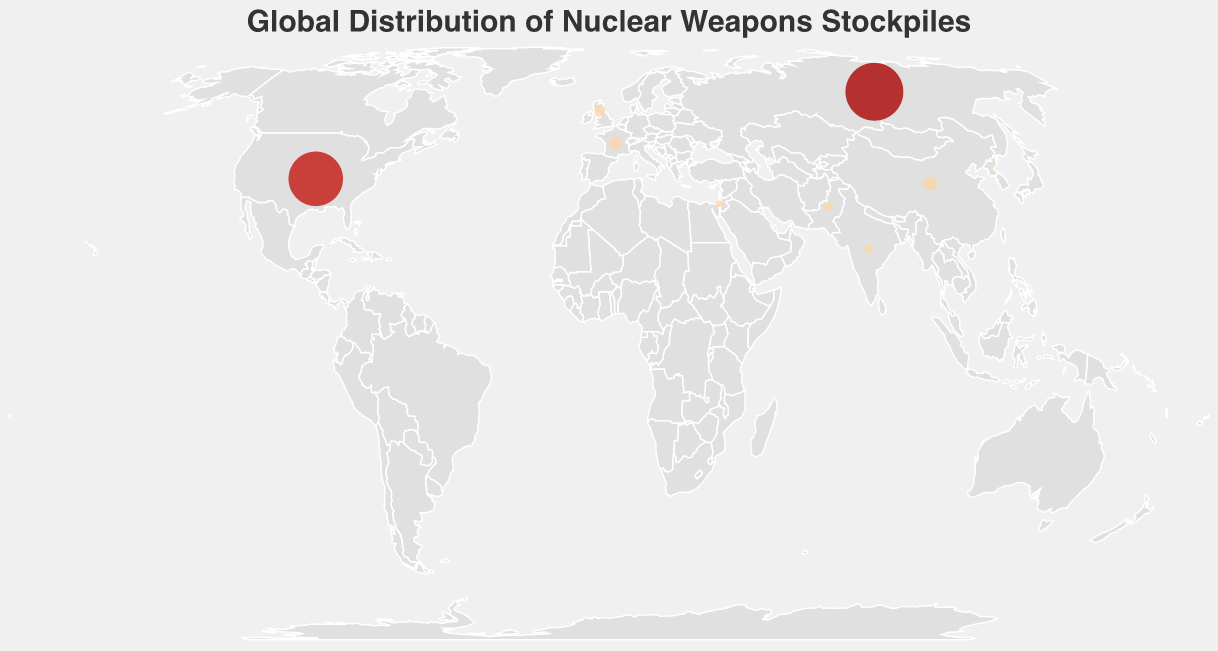What is the title of the plot? The title is displayed at the top of the plot in large text, detailing what the figure represents.
Answer: Global Distribution of Nuclear Weapons Stockpiles Which country has the highest number of nuclear warheads? By inspecting the size and tooltip of each circle, one can determine which country represents the largest number of warheads. In this case, it's Russia.
Answer: Russia How many countries in the plot have zero nuclear warheads? We count the number of countries that have a tooltip showing "Nuclear Warheads: 0".
Answer: 7 Which countries have nuclear warheads counts between 100 and 200? Identify countries with circle sizes indicating 100 to 200 and verify by checking their tooltips.
Answer: Pakistan and India Compare the nuclear warhead stockpiles of China and France. Which one has more, and by how much? Look at the sizes of the circles representing China and France and check the tooltips for their exact values. China has 350, whereas France has 290. The difference is 350 - 290 = 60.
Answer: China, by 60 What is the total number of nuclear warheads of Israel and North Korea combined? By adding Israel's and North Korea's warheads (90 + 40), you can determine the combined amount.
Answer: 130 What is the difference in nuclear warheads between India and Pakistan? Refer to the tooltips for India and Pakistan to find that India has 156 and Pakistan has 165. The difference is 165 - 156 = 9.
Answer: 9 Which country has the smallest number of nuclear warheads among those that possess them, and how many? Inspect the tooltips of circles with a non-zero value; the smallest number noticed is 40, belonging to North Korea.
Answer: North Korea, 40 What is the average number of nuclear warheads for countries with more than 5000 warheads? Identify countries exceeding 5000 warheads (United States and Russia) and calculate their average: (5550 + 6257) / 2 = 5903.5
Answer: 5903.5 Which continent has the most countries with zero nuclear warheads? By analyzing the geographic locations, identify the continents represented in the dataset and count countries with zero warheads in each. Africa has South Africa, South America has Brazil and Argentina.
Answer: South America 